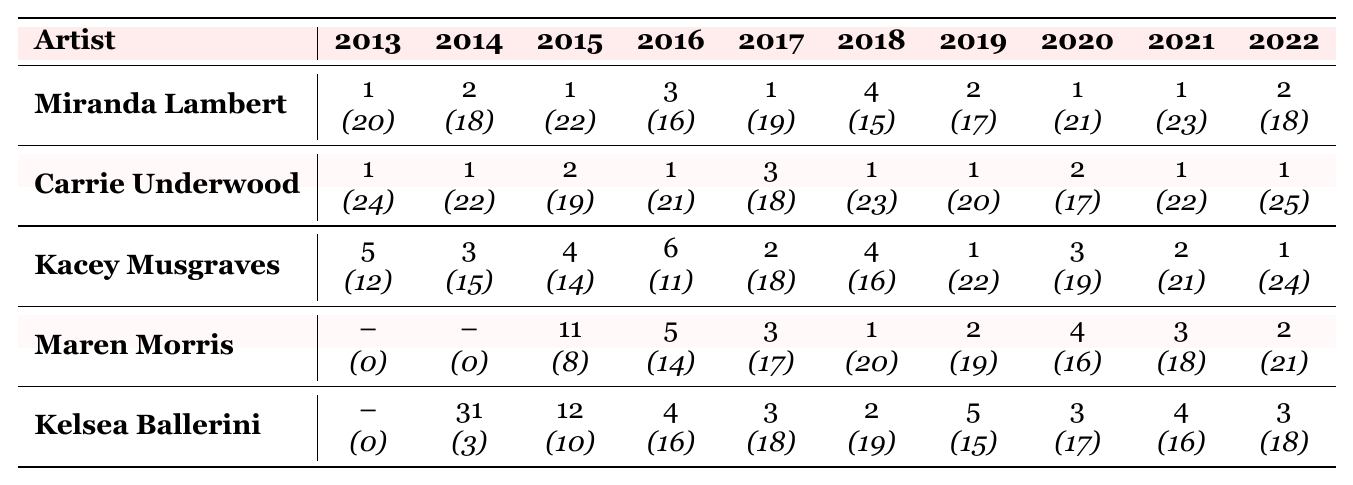What is the peak position of Miranda Lambert in 2015? According to the table, Miranda Lambert reached her peak position of 1 in 2015.
Answer: 1 What artist had the highest number of weeks on the chart in 2022? Checking the table for the number of weeks on the chart in 2022, Carrie Underwood had the highest value of 25 weeks.
Answer: Carrie Underwood How many weeks did Kacey Musgraves spend on the chart in 2013? For Kacey Musgraves in 2013, the table shows she spent 12 weeks on the chart.
Answer: 12 Which artist had the highest peak position overall across all years? Looking through the data, both Miranda Lambert and Carrie Underwood peaked at position 1 multiple times, making them the highest overall.
Answer: Miranda Lambert and Carrie Underwood What is the average peak position of Kelsea Ballerini over the years she appears? Kelsea Ballerini's peak positions are 31, 12, 4, 3, 2, 5, 3, 4, and 3. Adding them gives: 31 + 12 + 4 + 3 + 2 + 5 + 3 + 4 + 3 = 63. There are 9 values, so the average is 63/9 = 7.
Answer: 7 Did Maren Morris ever reach the top 10 in peak position? Referring to Maren Morris's peak positions, she achieved a peak of 5, meaning she did reach the top 10.
Answer: Yes Which artist had the most consistent peak positions over the decade? Analyzing the peak positions of each artist, Carrie Underwood shows the most consistency with peak positions between 1 and 3 in all years but one.
Answer: Carrie Underwood How many total weeks did Miranda Lambert spend on the chart from 2013 to 2022? Summing Miranda Lambert's weeks on the chart: 20 + 18 + 22 + 16 + 19 + 15 + 17 + 21 + 23 + 18 = 189 weeks total.
Answer: 189 What is the difference in weeks on the chart between Kacey Musgraves in 2019 and 2020? Kacey Musgraves was on the chart for 22 weeks in 2019 and 19 weeks in 2020. The difference is 22 - 19 = 3 weeks.
Answer: 3 Who had the least weeks on the chart in 2013? Kelsea Ballerini did not appear on the chart in 2013, as indicated by the 0 weeks.
Answer: Kelsea Ballerini 